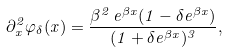<formula> <loc_0><loc_0><loc_500><loc_500>\partial _ { x } ^ { 2 } \varphi _ { \delta } ( x ) = \frac { \beta ^ { 2 } \, e ^ { \beta x } ( 1 - \delta e ^ { \beta x } ) } { ( 1 + \delta e ^ { \beta x } ) ^ { 3 } } ,</formula> 